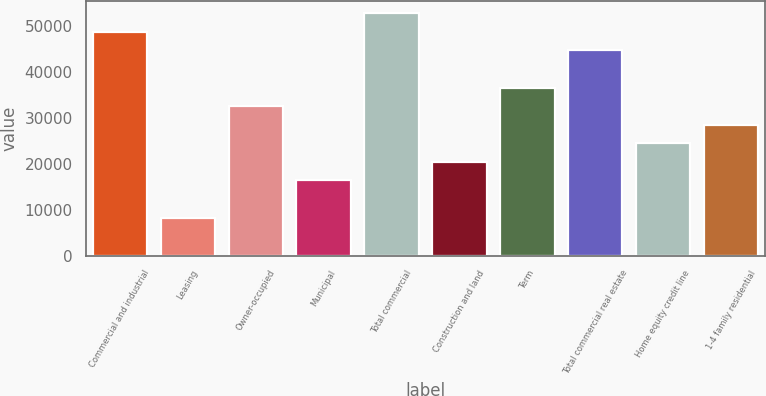Convert chart to OTSL. <chart><loc_0><loc_0><loc_500><loc_500><bar_chart><fcel>Commercial and industrial<fcel>Leasing<fcel>Owner-occupied<fcel>Municipal<fcel>Total commercial<fcel>Construction and land<fcel>Term<fcel>Total commercial real estate<fcel>Home equity credit line<fcel>1-4 family residential<nl><fcel>48742.6<fcel>8279.6<fcel>32557.4<fcel>16372.2<fcel>52788.9<fcel>20418.5<fcel>36603.7<fcel>44696.3<fcel>24464.8<fcel>28511.1<nl></chart> 